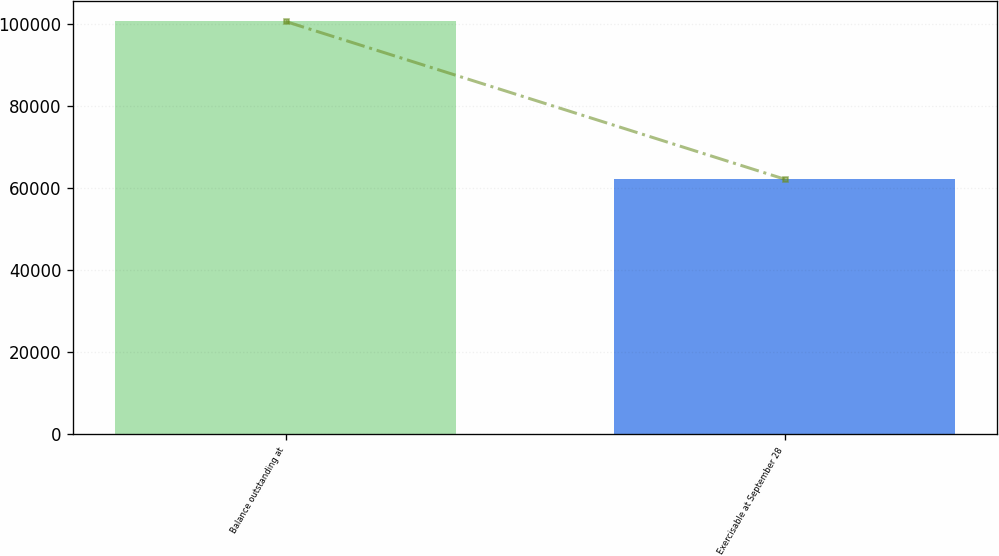Convert chart. <chart><loc_0><loc_0><loc_500><loc_500><bar_chart><fcel>Balance outstanding at<fcel>Exercisable at September 28<nl><fcel>100504<fcel>62098<nl></chart> 